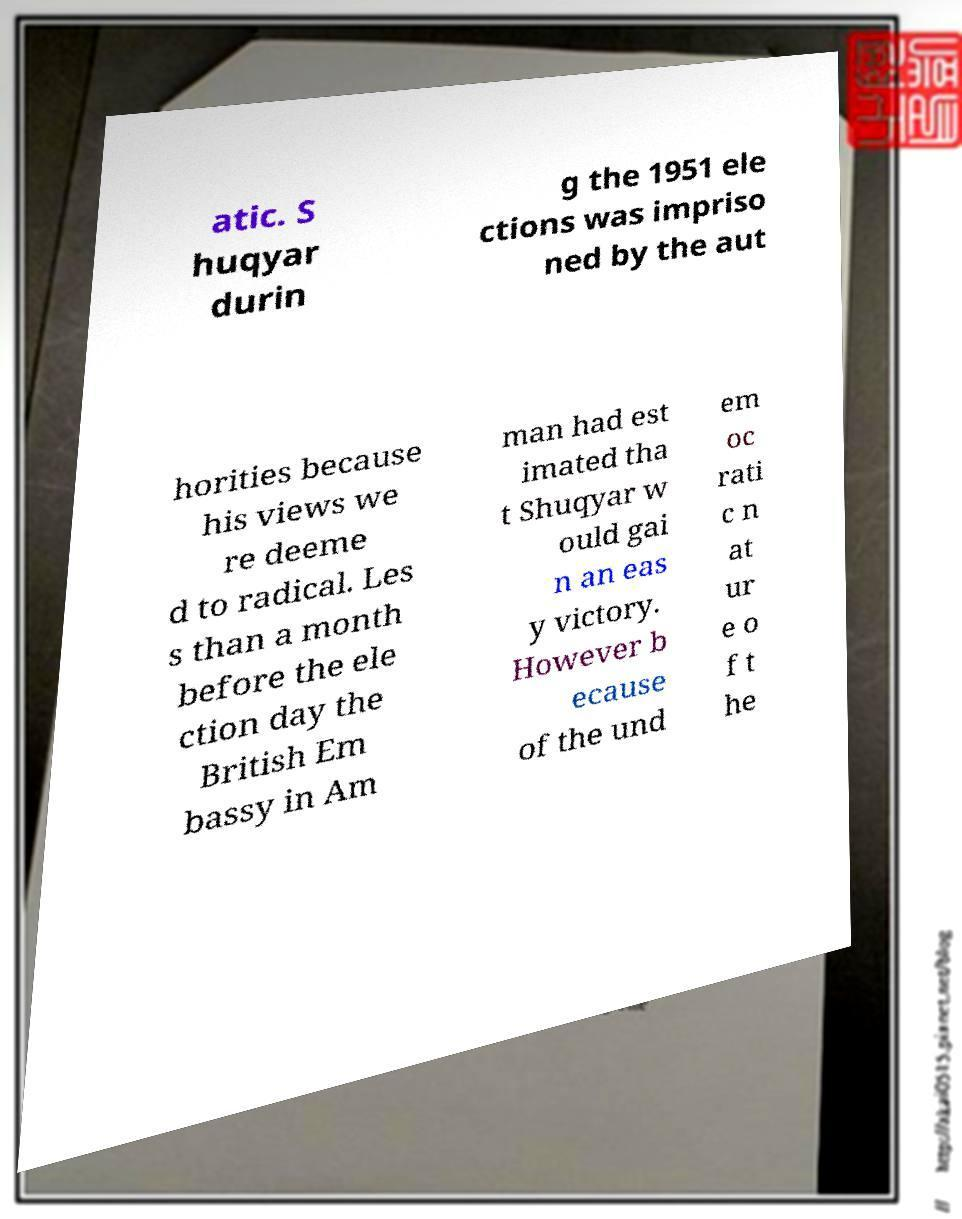Please read and relay the text visible in this image. What does it say? atic. S huqyar durin g the 1951 ele ctions was impriso ned by the aut horities because his views we re deeme d to radical. Les s than a month before the ele ction day the British Em bassy in Am man had est imated tha t Shuqyar w ould gai n an eas y victory. However b ecause of the und em oc rati c n at ur e o f t he 